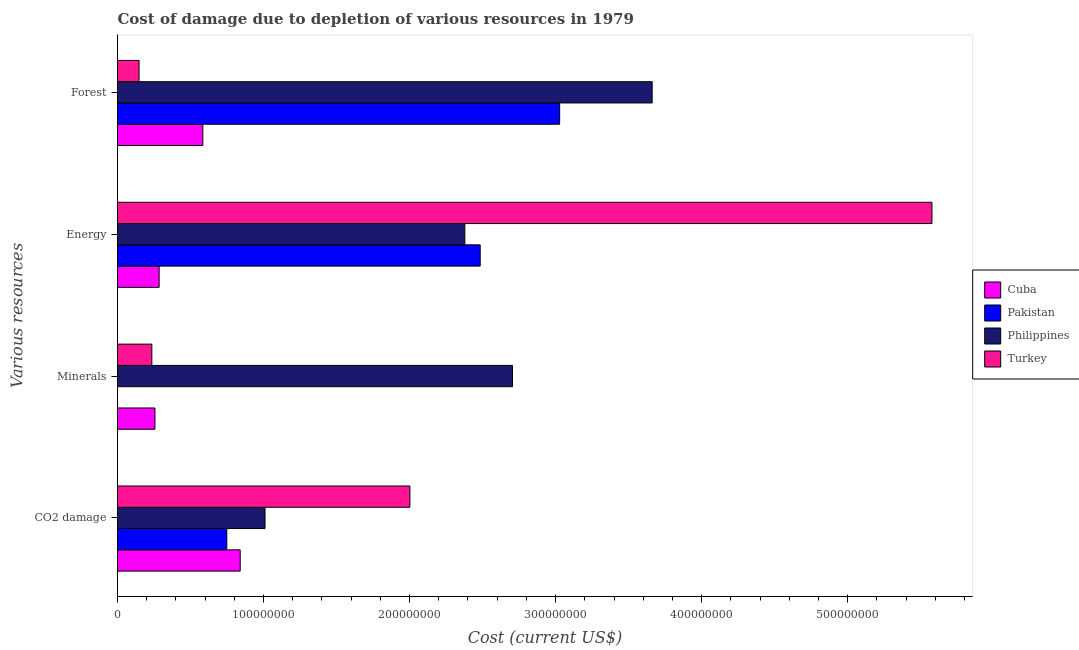How many different coloured bars are there?
Make the answer very short. 4. Are the number of bars on each tick of the Y-axis equal?
Your response must be concise. Yes. What is the label of the 2nd group of bars from the top?
Provide a succinct answer. Energy. What is the cost of damage due to depletion of coal in Pakistan?
Offer a very short reply. 7.48e+07. Across all countries, what is the maximum cost of damage due to depletion of coal?
Provide a succinct answer. 2.00e+08. Across all countries, what is the minimum cost of damage due to depletion of coal?
Keep it short and to the point. 7.48e+07. In which country was the cost of damage due to depletion of coal maximum?
Your answer should be compact. Turkey. In which country was the cost of damage due to depletion of coal minimum?
Your answer should be compact. Pakistan. What is the total cost of damage due to depletion of coal in the graph?
Offer a terse response. 4.60e+08. What is the difference between the cost of damage due to depletion of energy in Cuba and that in Pakistan?
Make the answer very short. -2.20e+08. What is the difference between the cost of damage due to depletion of energy in Turkey and the cost of damage due to depletion of coal in Philippines?
Give a very brief answer. 4.57e+08. What is the average cost of damage due to depletion of forests per country?
Ensure brevity in your answer.  1.86e+08. What is the difference between the cost of damage due to depletion of forests and cost of damage due to depletion of energy in Pakistan?
Provide a short and direct response. 5.44e+07. In how many countries, is the cost of damage due to depletion of energy greater than 440000000 US$?
Your answer should be compact. 1. What is the ratio of the cost of damage due to depletion of coal in Cuba to that in Turkey?
Offer a very short reply. 0.42. Is the cost of damage due to depletion of coal in Turkey less than that in Cuba?
Ensure brevity in your answer.  No. Is the difference between the cost of damage due to depletion of energy in Philippines and Cuba greater than the difference between the cost of damage due to depletion of coal in Philippines and Cuba?
Your answer should be compact. Yes. What is the difference between the highest and the second highest cost of damage due to depletion of coal?
Provide a succinct answer. 9.92e+07. What is the difference between the highest and the lowest cost of damage due to depletion of forests?
Your response must be concise. 3.51e+08. In how many countries, is the cost of damage due to depletion of forests greater than the average cost of damage due to depletion of forests taken over all countries?
Provide a short and direct response. 2. Is it the case that in every country, the sum of the cost of damage due to depletion of coal and cost of damage due to depletion of energy is greater than the sum of cost of damage due to depletion of minerals and cost of damage due to depletion of forests?
Your answer should be compact. No. What does the 1st bar from the bottom in Minerals represents?
Make the answer very short. Cuba. Are all the bars in the graph horizontal?
Your answer should be very brief. Yes. How many countries are there in the graph?
Provide a short and direct response. 4. Does the graph contain grids?
Offer a very short reply. No. Where does the legend appear in the graph?
Provide a short and direct response. Center right. How are the legend labels stacked?
Offer a very short reply. Vertical. What is the title of the graph?
Keep it short and to the point. Cost of damage due to depletion of various resources in 1979 . What is the label or title of the X-axis?
Your response must be concise. Cost (current US$). What is the label or title of the Y-axis?
Ensure brevity in your answer.  Various resources. What is the Cost (current US$) of Cuba in CO2 damage?
Give a very brief answer. 8.40e+07. What is the Cost (current US$) in Pakistan in CO2 damage?
Provide a succinct answer. 7.48e+07. What is the Cost (current US$) in Philippines in CO2 damage?
Your response must be concise. 1.01e+08. What is the Cost (current US$) of Turkey in CO2 damage?
Provide a short and direct response. 2.00e+08. What is the Cost (current US$) of Cuba in Minerals?
Your answer should be very brief. 2.56e+07. What is the Cost (current US$) of Pakistan in Minerals?
Your response must be concise. 1.06e+04. What is the Cost (current US$) in Philippines in Minerals?
Your answer should be very brief. 2.70e+08. What is the Cost (current US$) in Turkey in Minerals?
Keep it short and to the point. 2.35e+07. What is the Cost (current US$) of Cuba in Energy?
Keep it short and to the point. 2.85e+07. What is the Cost (current US$) in Pakistan in Energy?
Offer a terse response. 2.48e+08. What is the Cost (current US$) of Philippines in Energy?
Offer a very short reply. 2.38e+08. What is the Cost (current US$) in Turkey in Energy?
Give a very brief answer. 5.58e+08. What is the Cost (current US$) of Cuba in Forest?
Ensure brevity in your answer.  5.84e+07. What is the Cost (current US$) of Pakistan in Forest?
Provide a short and direct response. 3.03e+08. What is the Cost (current US$) in Philippines in Forest?
Make the answer very short. 3.66e+08. What is the Cost (current US$) of Turkey in Forest?
Keep it short and to the point. 1.48e+07. Across all Various resources, what is the maximum Cost (current US$) in Cuba?
Provide a succinct answer. 8.40e+07. Across all Various resources, what is the maximum Cost (current US$) of Pakistan?
Provide a succinct answer. 3.03e+08. Across all Various resources, what is the maximum Cost (current US$) of Philippines?
Ensure brevity in your answer.  3.66e+08. Across all Various resources, what is the maximum Cost (current US$) in Turkey?
Provide a short and direct response. 5.58e+08. Across all Various resources, what is the minimum Cost (current US$) in Cuba?
Ensure brevity in your answer.  2.56e+07. Across all Various resources, what is the minimum Cost (current US$) of Pakistan?
Provide a succinct answer. 1.06e+04. Across all Various resources, what is the minimum Cost (current US$) of Philippines?
Your answer should be very brief. 1.01e+08. Across all Various resources, what is the minimum Cost (current US$) in Turkey?
Make the answer very short. 1.48e+07. What is the total Cost (current US$) in Cuba in the graph?
Your response must be concise. 1.97e+08. What is the total Cost (current US$) in Pakistan in the graph?
Your answer should be very brief. 6.26e+08. What is the total Cost (current US$) of Philippines in the graph?
Offer a very short reply. 9.75e+08. What is the total Cost (current US$) of Turkey in the graph?
Make the answer very short. 7.96e+08. What is the difference between the Cost (current US$) in Cuba in CO2 damage and that in Minerals?
Your answer should be compact. 5.84e+07. What is the difference between the Cost (current US$) in Pakistan in CO2 damage and that in Minerals?
Your response must be concise. 7.48e+07. What is the difference between the Cost (current US$) in Philippines in CO2 damage and that in Minerals?
Your answer should be very brief. -1.69e+08. What is the difference between the Cost (current US$) in Turkey in CO2 damage and that in Minerals?
Your answer should be compact. 1.77e+08. What is the difference between the Cost (current US$) of Cuba in CO2 damage and that in Energy?
Provide a succinct answer. 5.55e+07. What is the difference between the Cost (current US$) in Pakistan in CO2 damage and that in Energy?
Ensure brevity in your answer.  -1.74e+08. What is the difference between the Cost (current US$) of Philippines in CO2 damage and that in Energy?
Give a very brief answer. -1.37e+08. What is the difference between the Cost (current US$) in Turkey in CO2 damage and that in Energy?
Your answer should be compact. -3.58e+08. What is the difference between the Cost (current US$) of Cuba in CO2 damage and that in Forest?
Make the answer very short. 2.56e+07. What is the difference between the Cost (current US$) in Pakistan in CO2 damage and that in Forest?
Make the answer very short. -2.28e+08. What is the difference between the Cost (current US$) of Philippines in CO2 damage and that in Forest?
Provide a short and direct response. -2.65e+08. What is the difference between the Cost (current US$) in Turkey in CO2 damage and that in Forest?
Offer a very short reply. 1.85e+08. What is the difference between the Cost (current US$) of Cuba in Minerals and that in Energy?
Offer a very short reply. -2.86e+06. What is the difference between the Cost (current US$) in Pakistan in Minerals and that in Energy?
Offer a very short reply. -2.48e+08. What is the difference between the Cost (current US$) in Philippines in Minerals and that in Energy?
Give a very brief answer. 3.26e+07. What is the difference between the Cost (current US$) of Turkey in Minerals and that in Energy?
Your answer should be compact. -5.34e+08. What is the difference between the Cost (current US$) in Cuba in Minerals and that in Forest?
Your response must be concise. -3.28e+07. What is the difference between the Cost (current US$) in Pakistan in Minerals and that in Forest?
Make the answer very short. -3.03e+08. What is the difference between the Cost (current US$) in Philippines in Minerals and that in Forest?
Offer a very short reply. -9.56e+07. What is the difference between the Cost (current US$) of Turkey in Minerals and that in Forest?
Offer a very short reply. 8.75e+06. What is the difference between the Cost (current US$) of Cuba in Energy and that in Forest?
Your answer should be very brief. -2.99e+07. What is the difference between the Cost (current US$) of Pakistan in Energy and that in Forest?
Offer a terse response. -5.44e+07. What is the difference between the Cost (current US$) of Philippines in Energy and that in Forest?
Offer a very short reply. -1.28e+08. What is the difference between the Cost (current US$) of Turkey in Energy and that in Forest?
Your response must be concise. 5.43e+08. What is the difference between the Cost (current US$) in Cuba in CO2 damage and the Cost (current US$) in Pakistan in Minerals?
Make the answer very short. 8.40e+07. What is the difference between the Cost (current US$) of Cuba in CO2 damage and the Cost (current US$) of Philippines in Minerals?
Your answer should be compact. -1.86e+08. What is the difference between the Cost (current US$) in Cuba in CO2 damage and the Cost (current US$) in Turkey in Minerals?
Your answer should be compact. 6.05e+07. What is the difference between the Cost (current US$) of Pakistan in CO2 damage and the Cost (current US$) of Philippines in Minerals?
Provide a succinct answer. -1.96e+08. What is the difference between the Cost (current US$) in Pakistan in CO2 damage and the Cost (current US$) in Turkey in Minerals?
Ensure brevity in your answer.  5.13e+07. What is the difference between the Cost (current US$) of Philippines in CO2 damage and the Cost (current US$) of Turkey in Minerals?
Offer a very short reply. 7.75e+07. What is the difference between the Cost (current US$) in Cuba in CO2 damage and the Cost (current US$) in Pakistan in Energy?
Offer a very short reply. -1.64e+08. What is the difference between the Cost (current US$) of Cuba in CO2 damage and the Cost (current US$) of Philippines in Energy?
Give a very brief answer. -1.54e+08. What is the difference between the Cost (current US$) of Cuba in CO2 damage and the Cost (current US$) of Turkey in Energy?
Your answer should be very brief. -4.74e+08. What is the difference between the Cost (current US$) of Pakistan in CO2 damage and the Cost (current US$) of Philippines in Energy?
Make the answer very short. -1.63e+08. What is the difference between the Cost (current US$) in Pakistan in CO2 damage and the Cost (current US$) in Turkey in Energy?
Your answer should be compact. -4.83e+08. What is the difference between the Cost (current US$) of Philippines in CO2 damage and the Cost (current US$) of Turkey in Energy?
Your response must be concise. -4.57e+08. What is the difference between the Cost (current US$) of Cuba in CO2 damage and the Cost (current US$) of Pakistan in Forest?
Make the answer very short. -2.19e+08. What is the difference between the Cost (current US$) in Cuba in CO2 damage and the Cost (current US$) in Philippines in Forest?
Make the answer very short. -2.82e+08. What is the difference between the Cost (current US$) in Cuba in CO2 damage and the Cost (current US$) in Turkey in Forest?
Your answer should be very brief. 6.92e+07. What is the difference between the Cost (current US$) in Pakistan in CO2 damage and the Cost (current US$) in Philippines in Forest?
Keep it short and to the point. -2.91e+08. What is the difference between the Cost (current US$) of Pakistan in CO2 damage and the Cost (current US$) of Turkey in Forest?
Make the answer very short. 6.01e+07. What is the difference between the Cost (current US$) in Philippines in CO2 damage and the Cost (current US$) in Turkey in Forest?
Offer a very short reply. 8.63e+07. What is the difference between the Cost (current US$) of Cuba in Minerals and the Cost (current US$) of Pakistan in Energy?
Make the answer very short. -2.23e+08. What is the difference between the Cost (current US$) in Cuba in Minerals and the Cost (current US$) in Philippines in Energy?
Your answer should be compact. -2.12e+08. What is the difference between the Cost (current US$) in Cuba in Minerals and the Cost (current US$) in Turkey in Energy?
Make the answer very short. -5.32e+08. What is the difference between the Cost (current US$) of Pakistan in Minerals and the Cost (current US$) of Philippines in Energy?
Your answer should be compact. -2.38e+08. What is the difference between the Cost (current US$) in Pakistan in Minerals and the Cost (current US$) in Turkey in Energy?
Provide a succinct answer. -5.58e+08. What is the difference between the Cost (current US$) of Philippines in Minerals and the Cost (current US$) of Turkey in Energy?
Your response must be concise. -2.87e+08. What is the difference between the Cost (current US$) of Cuba in Minerals and the Cost (current US$) of Pakistan in Forest?
Your response must be concise. -2.77e+08. What is the difference between the Cost (current US$) of Cuba in Minerals and the Cost (current US$) of Philippines in Forest?
Your answer should be compact. -3.40e+08. What is the difference between the Cost (current US$) of Cuba in Minerals and the Cost (current US$) of Turkey in Forest?
Give a very brief answer. 1.09e+07. What is the difference between the Cost (current US$) of Pakistan in Minerals and the Cost (current US$) of Philippines in Forest?
Give a very brief answer. -3.66e+08. What is the difference between the Cost (current US$) of Pakistan in Minerals and the Cost (current US$) of Turkey in Forest?
Offer a terse response. -1.48e+07. What is the difference between the Cost (current US$) in Philippines in Minerals and the Cost (current US$) in Turkey in Forest?
Ensure brevity in your answer.  2.56e+08. What is the difference between the Cost (current US$) of Cuba in Energy and the Cost (current US$) of Pakistan in Forest?
Your answer should be compact. -2.74e+08. What is the difference between the Cost (current US$) of Cuba in Energy and the Cost (current US$) of Philippines in Forest?
Provide a succinct answer. -3.38e+08. What is the difference between the Cost (current US$) of Cuba in Energy and the Cost (current US$) of Turkey in Forest?
Provide a succinct answer. 1.37e+07. What is the difference between the Cost (current US$) in Pakistan in Energy and the Cost (current US$) in Philippines in Forest?
Provide a succinct answer. -1.18e+08. What is the difference between the Cost (current US$) of Pakistan in Energy and the Cost (current US$) of Turkey in Forest?
Offer a very short reply. 2.34e+08. What is the difference between the Cost (current US$) of Philippines in Energy and the Cost (current US$) of Turkey in Forest?
Make the answer very short. 2.23e+08. What is the average Cost (current US$) in Cuba per Various resources?
Offer a very short reply. 4.92e+07. What is the average Cost (current US$) of Pakistan per Various resources?
Your answer should be compact. 1.56e+08. What is the average Cost (current US$) in Philippines per Various resources?
Ensure brevity in your answer.  2.44e+08. What is the average Cost (current US$) in Turkey per Various resources?
Ensure brevity in your answer.  1.99e+08. What is the difference between the Cost (current US$) of Cuba and Cost (current US$) of Pakistan in CO2 damage?
Offer a terse response. 9.17e+06. What is the difference between the Cost (current US$) of Cuba and Cost (current US$) of Philippines in CO2 damage?
Make the answer very short. -1.70e+07. What is the difference between the Cost (current US$) in Cuba and Cost (current US$) in Turkey in CO2 damage?
Offer a very short reply. -1.16e+08. What is the difference between the Cost (current US$) of Pakistan and Cost (current US$) of Philippines in CO2 damage?
Give a very brief answer. -2.62e+07. What is the difference between the Cost (current US$) of Pakistan and Cost (current US$) of Turkey in CO2 damage?
Your answer should be very brief. -1.25e+08. What is the difference between the Cost (current US$) in Philippines and Cost (current US$) in Turkey in CO2 damage?
Your answer should be very brief. -9.92e+07. What is the difference between the Cost (current US$) of Cuba and Cost (current US$) of Pakistan in Minerals?
Make the answer very short. 2.56e+07. What is the difference between the Cost (current US$) in Cuba and Cost (current US$) in Philippines in Minerals?
Your answer should be compact. -2.45e+08. What is the difference between the Cost (current US$) in Cuba and Cost (current US$) in Turkey in Minerals?
Provide a succinct answer. 2.13e+06. What is the difference between the Cost (current US$) of Pakistan and Cost (current US$) of Philippines in Minerals?
Provide a short and direct response. -2.70e+08. What is the difference between the Cost (current US$) in Pakistan and Cost (current US$) in Turkey in Minerals?
Offer a terse response. -2.35e+07. What is the difference between the Cost (current US$) of Philippines and Cost (current US$) of Turkey in Minerals?
Make the answer very short. 2.47e+08. What is the difference between the Cost (current US$) of Cuba and Cost (current US$) of Pakistan in Energy?
Make the answer very short. -2.20e+08. What is the difference between the Cost (current US$) of Cuba and Cost (current US$) of Philippines in Energy?
Provide a short and direct response. -2.09e+08. What is the difference between the Cost (current US$) of Cuba and Cost (current US$) of Turkey in Energy?
Provide a short and direct response. -5.29e+08. What is the difference between the Cost (current US$) in Pakistan and Cost (current US$) in Philippines in Energy?
Provide a succinct answer. 1.05e+07. What is the difference between the Cost (current US$) of Pakistan and Cost (current US$) of Turkey in Energy?
Make the answer very short. -3.09e+08. What is the difference between the Cost (current US$) in Philippines and Cost (current US$) in Turkey in Energy?
Your response must be concise. -3.20e+08. What is the difference between the Cost (current US$) of Cuba and Cost (current US$) of Pakistan in Forest?
Offer a very short reply. -2.44e+08. What is the difference between the Cost (current US$) in Cuba and Cost (current US$) in Philippines in Forest?
Ensure brevity in your answer.  -3.08e+08. What is the difference between the Cost (current US$) in Cuba and Cost (current US$) in Turkey in Forest?
Make the answer very short. 4.37e+07. What is the difference between the Cost (current US$) of Pakistan and Cost (current US$) of Philippines in Forest?
Ensure brevity in your answer.  -6.34e+07. What is the difference between the Cost (current US$) of Pakistan and Cost (current US$) of Turkey in Forest?
Provide a succinct answer. 2.88e+08. What is the difference between the Cost (current US$) of Philippines and Cost (current US$) of Turkey in Forest?
Offer a terse response. 3.51e+08. What is the ratio of the Cost (current US$) of Cuba in CO2 damage to that in Minerals?
Give a very brief answer. 3.28. What is the ratio of the Cost (current US$) of Pakistan in CO2 damage to that in Minerals?
Keep it short and to the point. 7066.88. What is the ratio of the Cost (current US$) in Philippines in CO2 damage to that in Minerals?
Provide a short and direct response. 0.37. What is the ratio of the Cost (current US$) of Turkey in CO2 damage to that in Minerals?
Provide a short and direct response. 8.51. What is the ratio of the Cost (current US$) of Cuba in CO2 damage to that in Energy?
Provide a short and direct response. 2.95. What is the ratio of the Cost (current US$) in Pakistan in CO2 damage to that in Energy?
Ensure brevity in your answer.  0.3. What is the ratio of the Cost (current US$) in Philippines in CO2 damage to that in Energy?
Your response must be concise. 0.42. What is the ratio of the Cost (current US$) in Turkey in CO2 damage to that in Energy?
Your answer should be very brief. 0.36. What is the ratio of the Cost (current US$) of Cuba in CO2 damage to that in Forest?
Ensure brevity in your answer.  1.44. What is the ratio of the Cost (current US$) in Pakistan in CO2 damage to that in Forest?
Your answer should be very brief. 0.25. What is the ratio of the Cost (current US$) of Philippines in CO2 damage to that in Forest?
Give a very brief answer. 0.28. What is the ratio of the Cost (current US$) of Turkey in CO2 damage to that in Forest?
Make the answer very short. 13.56. What is the ratio of the Cost (current US$) of Cuba in Minerals to that in Energy?
Make the answer very short. 0.9. What is the ratio of the Cost (current US$) of Pakistan in Minerals to that in Energy?
Your answer should be very brief. 0. What is the ratio of the Cost (current US$) of Philippines in Minerals to that in Energy?
Ensure brevity in your answer.  1.14. What is the ratio of the Cost (current US$) of Turkey in Minerals to that in Energy?
Give a very brief answer. 0.04. What is the ratio of the Cost (current US$) of Cuba in Minerals to that in Forest?
Your response must be concise. 0.44. What is the ratio of the Cost (current US$) of Pakistan in Minerals to that in Forest?
Offer a very short reply. 0. What is the ratio of the Cost (current US$) of Philippines in Minerals to that in Forest?
Provide a short and direct response. 0.74. What is the ratio of the Cost (current US$) of Turkey in Minerals to that in Forest?
Give a very brief answer. 1.59. What is the ratio of the Cost (current US$) of Cuba in Energy to that in Forest?
Provide a succinct answer. 0.49. What is the ratio of the Cost (current US$) in Pakistan in Energy to that in Forest?
Ensure brevity in your answer.  0.82. What is the ratio of the Cost (current US$) in Philippines in Energy to that in Forest?
Keep it short and to the point. 0.65. What is the ratio of the Cost (current US$) of Turkey in Energy to that in Forest?
Ensure brevity in your answer.  37.76. What is the difference between the highest and the second highest Cost (current US$) in Cuba?
Provide a succinct answer. 2.56e+07. What is the difference between the highest and the second highest Cost (current US$) in Pakistan?
Provide a succinct answer. 5.44e+07. What is the difference between the highest and the second highest Cost (current US$) in Philippines?
Ensure brevity in your answer.  9.56e+07. What is the difference between the highest and the second highest Cost (current US$) of Turkey?
Your answer should be very brief. 3.58e+08. What is the difference between the highest and the lowest Cost (current US$) in Cuba?
Your response must be concise. 5.84e+07. What is the difference between the highest and the lowest Cost (current US$) in Pakistan?
Offer a very short reply. 3.03e+08. What is the difference between the highest and the lowest Cost (current US$) of Philippines?
Your answer should be very brief. 2.65e+08. What is the difference between the highest and the lowest Cost (current US$) in Turkey?
Keep it short and to the point. 5.43e+08. 